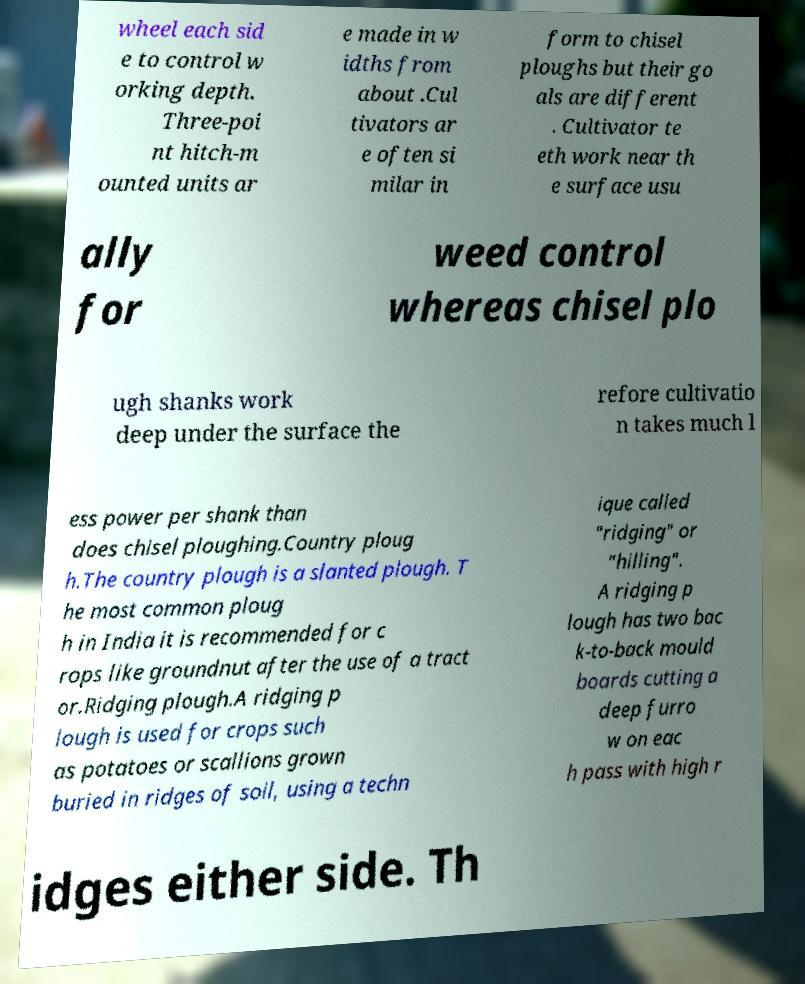What messages or text are displayed in this image? I need them in a readable, typed format. wheel each sid e to control w orking depth. Three-poi nt hitch-m ounted units ar e made in w idths from about .Cul tivators ar e often si milar in form to chisel ploughs but their go als are different . Cultivator te eth work near th e surface usu ally for weed control whereas chisel plo ugh shanks work deep under the surface the refore cultivatio n takes much l ess power per shank than does chisel ploughing.Country ploug h.The country plough is a slanted plough. T he most common ploug h in India it is recommended for c rops like groundnut after the use of a tract or.Ridging plough.A ridging p lough is used for crops such as potatoes or scallions grown buried in ridges of soil, using a techn ique called "ridging" or "hilling". A ridging p lough has two bac k-to-back mould boards cutting a deep furro w on eac h pass with high r idges either side. Th 